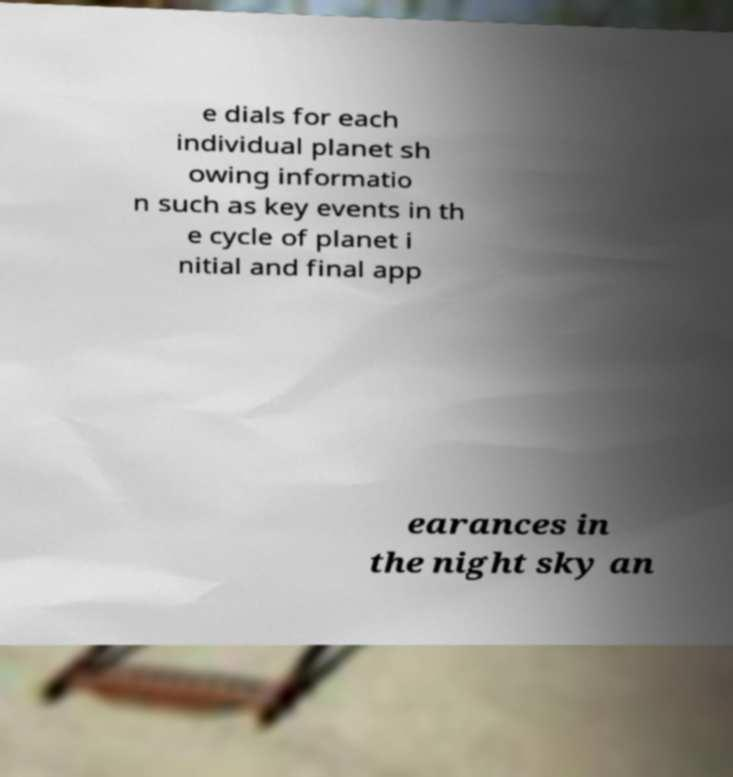I need the written content from this picture converted into text. Can you do that? e dials for each individual planet sh owing informatio n such as key events in th e cycle of planet i nitial and final app earances in the night sky an 